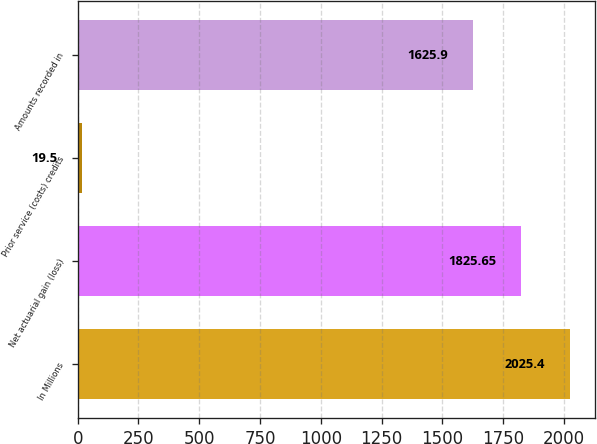Convert chart to OTSL. <chart><loc_0><loc_0><loc_500><loc_500><bar_chart><fcel>In Millions<fcel>Net actuarial gain (loss)<fcel>Prior service (costs) credits<fcel>Amounts recorded in<nl><fcel>2025.4<fcel>1825.65<fcel>19.5<fcel>1625.9<nl></chart> 